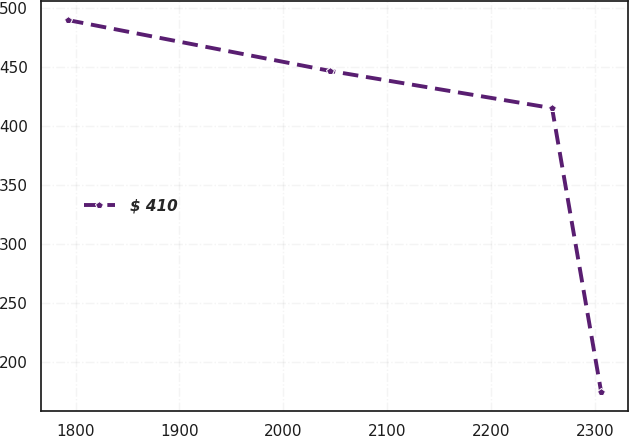<chart> <loc_0><loc_0><loc_500><loc_500><line_chart><ecel><fcel>$ 410<nl><fcel>1792.72<fcel>489.39<nl><fcel>2044.85<fcel>446.42<nl><fcel>2258.55<fcel>414.96<nl><fcel>2305.8<fcel>174.82<nl></chart> 